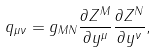<formula> <loc_0><loc_0><loc_500><loc_500>q _ { \mu \nu } = g _ { M N } \frac { \partial Z ^ { M } } { \partial y ^ { \mu } } \frac { \partial Z ^ { N } } { \partial y ^ { \nu } } ,</formula> 